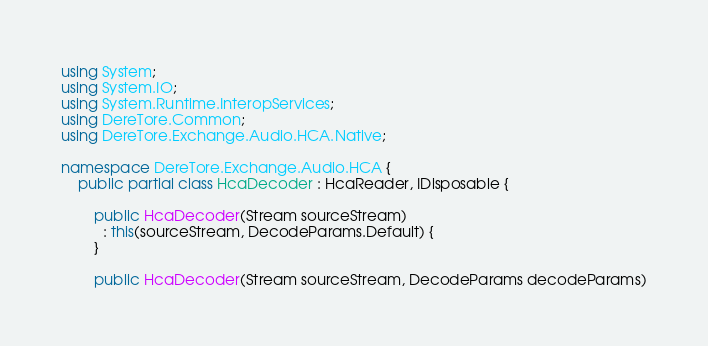<code> <loc_0><loc_0><loc_500><loc_500><_C#_>using System;
using System.IO;
using System.Runtime.InteropServices;
using DereTore.Common;
using DereTore.Exchange.Audio.HCA.Native;

namespace DereTore.Exchange.Audio.HCA {
    public partial class HcaDecoder : HcaReader, IDisposable {

        public HcaDecoder(Stream sourceStream)
          : this(sourceStream, DecodeParams.Default) {
        }

        public HcaDecoder(Stream sourceStream, DecodeParams decodeParams)</code> 